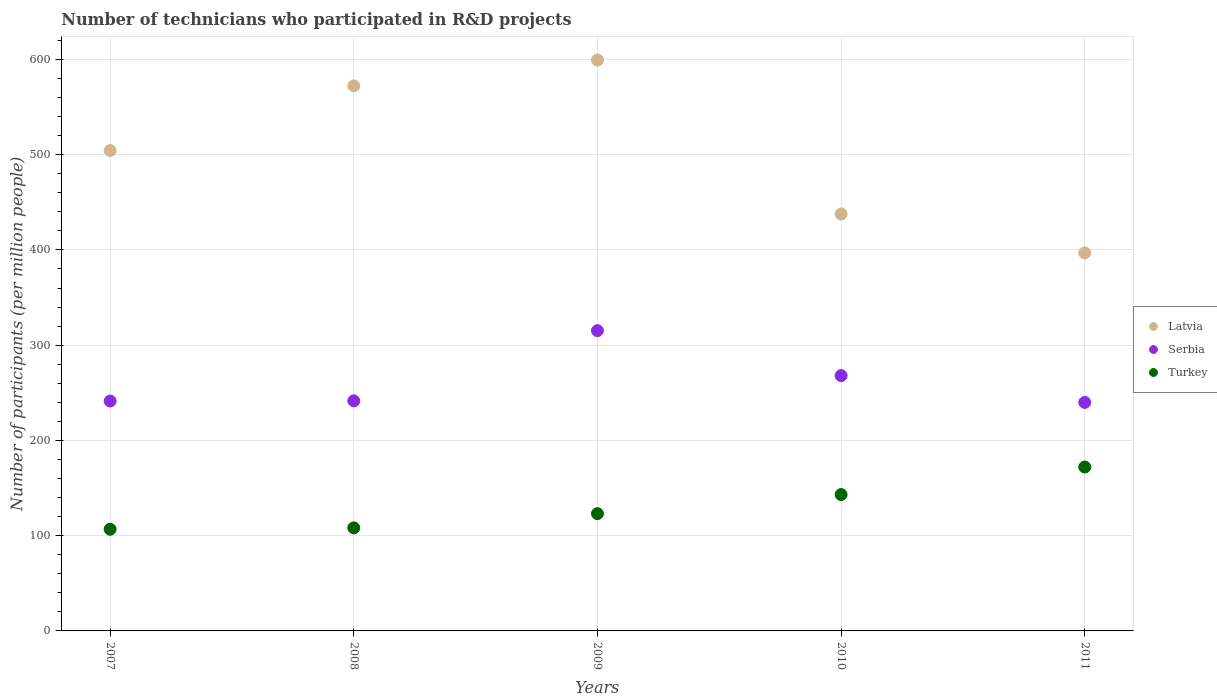What is the number of technicians who participated in R&D projects in Serbia in 2009?
Make the answer very short. 315.25. Across all years, what is the maximum number of technicians who participated in R&D projects in Latvia?
Ensure brevity in your answer.  599.35. Across all years, what is the minimum number of technicians who participated in R&D projects in Turkey?
Make the answer very short. 106.74. What is the total number of technicians who participated in R&D projects in Serbia in the graph?
Keep it short and to the point. 1306.11. What is the difference between the number of technicians who participated in R&D projects in Serbia in 2008 and that in 2009?
Give a very brief answer. -73.67. What is the difference between the number of technicians who participated in R&D projects in Turkey in 2009 and the number of technicians who participated in R&D projects in Latvia in 2008?
Make the answer very short. -449.12. What is the average number of technicians who participated in R&D projects in Serbia per year?
Offer a very short reply. 261.22. In the year 2007, what is the difference between the number of technicians who participated in R&D projects in Serbia and number of technicians who participated in R&D projects in Latvia?
Give a very brief answer. -262.94. What is the ratio of the number of technicians who participated in R&D projects in Latvia in 2008 to that in 2011?
Provide a short and direct response. 1.44. Is the number of technicians who participated in R&D projects in Latvia in 2009 less than that in 2010?
Your response must be concise. No. Is the difference between the number of technicians who participated in R&D projects in Serbia in 2009 and 2011 greater than the difference between the number of technicians who participated in R&D projects in Latvia in 2009 and 2011?
Offer a very short reply. No. What is the difference between the highest and the second highest number of technicians who participated in R&D projects in Latvia?
Your answer should be compact. 27.11. What is the difference between the highest and the lowest number of technicians who participated in R&D projects in Turkey?
Provide a succinct answer. 65.34. Does the number of technicians who participated in R&D projects in Serbia monotonically increase over the years?
Give a very brief answer. No. Is the number of technicians who participated in R&D projects in Latvia strictly greater than the number of technicians who participated in R&D projects in Serbia over the years?
Provide a succinct answer. Yes. Is the number of technicians who participated in R&D projects in Latvia strictly less than the number of technicians who participated in R&D projects in Serbia over the years?
Provide a short and direct response. No. How many dotlines are there?
Offer a terse response. 3. How many years are there in the graph?
Provide a short and direct response. 5. Are the values on the major ticks of Y-axis written in scientific E-notation?
Keep it short and to the point. No. Where does the legend appear in the graph?
Provide a succinct answer. Center right. How many legend labels are there?
Give a very brief answer. 3. What is the title of the graph?
Offer a very short reply. Number of technicians who participated in R&D projects. What is the label or title of the X-axis?
Provide a succinct answer. Years. What is the label or title of the Y-axis?
Provide a succinct answer. Number of participants (per million people). What is the Number of participants (per million people) of Latvia in 2007?
Provide a succinct answer. 504.29. What is the Number of participants (per million people) in Serbia in 2007?
Ensure brevity in your answer.  241.35. What is the Number of participants (per million people) of Turkey in 2007?
Give a very brief answer. 106.74. What is the Number of participants (per million people) of Latvia in 2008?
Provide a short and direct response. 572.24. What is the Number of participants (per million people) in Serbia in 2008?
Make the answer very short. 241.58. What is the Number of participants (per million people) of Turkey in 2008?
Keep it short and to the point. 108.21. What is the Number of participants (per million people) of Latvia in 2009?
Offer a very short reply. 599.35. What is the Number of participants (per million people) in Serbia in 2009?
Make the answer very short. 315.25. What is the Number of participants (per million people) in Turkey in 2009?
Your answer should be very brief. 123.12. What is the Number of participants (per million people) of Latvia in 2010?
Provide a succinct answer. 437.69. What is the Number of participants (per million people) in Serbia in 2010?
Give a very brief answer. 268.03. What is the Number of participants (per million people) in Turkey in 2010?
Your answer should be compact. 143.16. What is the Number of participants (per million people) in Latvia in 2011?
Offer a very short reply. 396.87. What is the Number of participants (per million people) of Serbia in 2011?
Ensure brevity in your answer.  239.9. What is the Number of participants (per million people) in Turkey in 2011?
Offer a terse response. 172.08. Across all years, what is the maximum Number of participants (per million people) of Latvia?
Ensure brevity in your answer.  599.35. Across all years, what is the maximum Number of participants (per million people) of Serbia?
Your response must be concise. 315.25. Across all years, what is the maximum Number of participants (per million people) of Turkey?
Give a very brief answer. 172.08. Across all years, what is the minimum Number of participants (per million people) of Latvia?
Provide a succinct answer. 396.87. Across all years, what is the minimum Number of participants (per million people) in Serbia?
Keep it short and to the point. 239.9. Across all years, what is the minimum Number of participants (per million people) in Turkey?
Offer a very short reply. 106.74. What is the total Number of participants (per million people) in Latvia in the graph?
Ensure brevity in your answer.  2510.43. What is the total Number of participants (per million people) of Serbia in the graph?
Keep it short and to the point. 1306.11. What is the total Number of participants (per million people) in Turkey in the graph?
Your response must be concise. 653.3. What is the difference between the Number of participants (per million people) in Latvia in 2007 and that in 2008?
Keep it short and to the point. -67.95. What is the difference between the Number of participants (per million people) in Serbia in 2007 and that in 2008?
Ensure brevity in your answer.  -0.23. What is the difference between the Number of participants (per million people) of Turkey in 2007 and that in 2008?
Your answer should be compact. -1.47. What is the difference between the Number of participants (per million people) in Latvia in 2007 and that in 2009?
Your response must be concise. -95.06. What is the difference between the Number of participants (per million people) of Serbia in 2007 and that in 2009?
Give a very brief answer. -73.9. What is the difference between the Number of participants (per million people) of Turkey in 2007 and that in 2009?
Your answer should be compact. -16.38. What is the difference between the Number of participants (per million people) of Latvia in 2007 and that in 2010?
Your answer should be very brief. 66.6. What is the difference between the Number of participants (per million people) of Serbia in 2007 and that in 2010?
Your response must be concise. -26.68. What is the difference between the Number of participants (per million people) of Turkey in 2007 and that in 2010?
Provide a short and direct response. -36.42. What is the difference between the Number of participants (per million people) in Latvia in 2007 and that in 2011?
Provide a succinct answer. 107.42. What is the difference between the Number of participants (per million people) in Serbia in 2007 and that in 2011?
Offer a terse response. 1.45. What is the difference between the Number of participants (per million people) in Turkey in 2007 and that in 2011?
Your answer should be compact. -65.34. What is the difference between the Number of participants (per million people) in Latvia in 2008 and that in 2009?
Give a very brief answer. -27.11. What is the difference between the Number of participants (per million people) of Serbia in 2008 and that in 2009?
Provide a short and direct response. -73.67. What is the difference between the Number of participants (per million people) in Turkey in 2008 and that in 2009?
Make the answer very short. -14.91. What is the difference between the Number of participants (per million people) in Latvia in 2008 and that in 2010?
Provide a succinct answer. 134.55. What is the difference between the Number of participants (per million people) in Serbia in 2008 and that in 2010?
Offer a very short reply. -26.45. What is the difference between the Number of participants (per million people) in Turkey in 2008 and that in 2010?
Your answer should be compact. -34.95. What is the difference between the Number of participants (per million people) in Latvia in 2008 and that in 2011?
Give a very brief answer. 175.37. What is the difference between the Number of participants (per million people) in Serbia in 2008 and that in 2011?
Offer a very short reply. 1.69. What is the difference between the Number of participants (per million people) of Turkey in 2008 and that in 2011?
Your answer should be compact. -63.87. What is the difference between the Number of participants (per million people) of Latvia in 2009 and that in 2010?
Your answer should be very brief. 161.66. What is the difference between the Number of participants (per million people) in Serbia in 2009 and that in 2010?
Offer a terse response. 47.22. What is the difference between the Number of participants (per million people) in Turkey in 2009 and that in 2010?
Keep it short and to the point. -20.04. What is the difference between the Number of participants (per million people) of Latvia in 2009 and that in 2011?
Your answer should be very brief. 202.48. What is the difference between the Number of participants (per million people) of Serbia in 2009 and that in 2011?
Offer a terse response. 75.36. What is the difference between the Number of participants (per million people) of Turkey in 2009 and that in 2011?
Your response must be concise. -48.96. What is the difference between the Number of participants (per million people) of Latvia in 2010 and that in 2011?
Your answer should be compact. 40.82. What is the difference between the Number of participants (per million people) of Serbia in 2010 and that in 2011?
Your response must be concise. 28.13. What is the difference between the Number of participants (per million people) of Turkey in 2010 and that in 2011?
Your answer should be compact. -28.92. What is the difference between the Number of participants (per million people) in Latvia in 2007 and the Number of participants (per million people) in Serbia in 2008?
Provide a short and direct response. 262.71. What is the difference between the Number of participants (per million people) in Latvia in 2007 and the Number of participants (per million people) in Turkey in 2008?
Give a very brief answer. 396.08. What is the difference between the Number of participants (per million people) in Serbia in 2007 and the Number of participants (per million people) in Turkey in 2008?
Provide a succinct answer. 133.14. What is the difference between the Number of participants (per million people) in Latvia in 2007 and the Number of participants (per million people) in Serbia in 2009?
Your answer should be very brief. 189.04. What is the difference between the Number of participants (per million people) in Latvia in 2007 and the Number of participants (per million people) in Turkey in 2009?
Make the answer very short. 381.17. What is the difference between the Number of participants (per million people) of Serbia in 2007 and the Number of participants (per million people) of Turkey in 2009?
Provide a succinct answer. 118.23. What is the difference between the Number of participants (per million people) of Latvia in 2007 and the Number of participants (per million people) of Serbia in 2010?
Provide a succinct answer. 236.26. What is the difference between the Number of participants (per million people) in Latvia in 2007 and the Number of participants (per million people) in Turkey in 2010?
Provide a short and direct response. 361.13. What is the difference between the Number of participants (per million people) in Serbia in 2007 and the Number of participants (per million people) in Turkey in 2010?
Provide a succinct answer. 98.19. What is the difference between the Number of participants (per million people) of Latvia in 2007 and the Number of participants (per million people) of Serbia in 2011?
Your answer should be compact. 264.39. What is the difference between the Number of participants (per million people) of Latvia in 2007 and the Number of participants (per million people) of Turkey in 2011?
Give a very brief answer. 332.21. What is the difference between the Number of participants (per million people) in Serbia in 2007 and the Number of participants (per million people) in Turkey in 2011?
Offer a very short reply. 69.27. What is the difference between the Number of participants (per million people) in Latvia in 2008 and the Number of participants (per million people) in Serbia in 2009?
Provide a succinct answer. 256.99. What is the difference between the Number of participants (per million people) in Latvia in 2008 and the Number of participants (per million people) in Turkey in 2009?
Provide a succinct answer. 449.12. What is the difference between the Number of participants (per million people) of Serbia in 2008 and the Number of participants (per million people) of Turkey in 2009?
Your response must be concise. 118.46. What is the difference between the Number of participants (per million people) of Latvia in 2008 and the Number of participants (per million people) of Serbia in 2010?
Make the answer very short. 304.21. What is the difference between the Number of participants (per million people) of Latvia in 2008 and the Number of participants (per million people) of Turkey in 2010?
Your answer should be very brief. 429.08. What is the difference between the Number of participants (per million people) in Serbia in 2008 and the Number of participants (per million people) in Turkey in 2010?
Your response must be concise. 98.42. What is the difference between the Number of participants (per million people) of Latvia in 2008 and the Number of participants (per million people) of Serbia in 2011?
Your answer should be compact. 332.34. What is the difference between the Number of participants (per million people) in Latvia in 2008 and the Number of participants (per million people) in Turkey in 2011?
Your response must be concise. 400.16. What is the difference between the Number of participants (per million people) in Serbia in 2008 and the Number of participants (per million people) in Turkey in 2011?
Your answer should be very brief. 69.5. What is the difference between the Number of participants (per million people) of Latvia in 2009 and the Number of participants (per million people) of Serbia in 2010?
Your answer should be very brief. 331.32. What is the difference between the Number of participants (per million people) of Latvia in 2009 and the Number of participants (per million people) of Turkey in 2010?
Offer a terse response. 456.19. What is the difference between the Number of participants (per million people) in Serbia in 2009 and the Number of participants (per million people) in Turkey in 2010?
Keep it short and to the point. 172.09. What is the difference between the Number of participants (per million people) in Latvia in 2009 and the Number of participants (per million people) in Serbia in 2011?
Provide a succinct answer. 359.45. What is the difference between the Number of participants (per million people) in Latvia in 2009 and the Number of participants (per million people) in Turkey in 2011?
Provide a succinct answer. 427.27. What is the difference between the Number of participants (per million people) in Serbia in 2009 and the Number of participants (per million people) in Turkey in 2011?
Your response must be concise. 143.17. What is the difference between the Number of participants (per million people) of Latvia in 2010 and the Number of participants (per million people) of Serbia in 2011?
Provide a short and direct response. 197.79. What is the difference between the Number of participants (per million people) of Latvia in 2010 and the Number of participants (per million people) of Turkey in 2011?
Keep it short and to the point. 265.61. What is the difference between the Number of participants (per million people) in Serbia in 2010 and the Number of participants (per million people) in Turkey in 2011?
Offer a very short reply. 95.95. What is the average Number of participants (per million people) of Latvia per year?
Give a very brief answer. 502.09. What is the average Number of participants (per million people) in Serbia per year?
Make the answer very short. 261.22. What is the average Number of participants (per million people) in Turkey per year?
Your answer should be compact. 130.66. In the year 2007, what is the difference between the Number of participants (per million people) of Latvia and Number of participants (per million people) of Serbia?
Keep it short and to the point. 262.94. In the year 2007, what is the difference between the Number of participants (per million people) of Latvia and Number of participants (per million people) of Turkey?
Your answer should be compact. 397.55. In the year 2007, what is the difference between the Number of participants (per million people) in Serbia and Number of participants (per million people) in Turkey?
Your response must be concise. 134.61. In the year 2008, what is the difference between the Number of participants (per million people) of Latvia and Number of participants (per million people) of Serbia?
Your answer should be compact. 330.66. In the year 2008, what is the difference between the Number of participants (per million people) in Latvia and Number of participants (per million people) in Turkey?
Give a very brief answer. 464.03. In the year 2008, what is the difference between the Number of participants (per million people) in Serbia and Number of participants (per million people) in Turkey?
Provide a succinct answer. 133.37. In the year 2009, what is the difference between the Number of participants (per million people) in Latvia and Number of participants (per million people) in Serbia?
Provide a succinct answer. 284.09. In the year 2009, what is the difference between the Number of participants (per million people) of Latvia and Number of participants (per million people) of Turkey?
Make the answer very short. 476.23. In the year 2009, what is the difference between the Number of participants (per million people) in Serbia and Number of participants (per million people) in Turkey?
Provide a short and direct response. 192.13. In the year 2010, what is the difference between the Number of participants (per million people) in Latvia and Number of participants (per million people) in Serbia?
Offer a terse response. 169.66. In the year 2010, what is the difference between the Number of participants (per million people) of Latvia and Number of participants (per million people) of Turkey?
Your answer should be very brief. 294.53. In the year 2010, what is the difference between the Number of participants (per million people) of Serbia and Number of participants (per million people) of Turkey?
Your answer should be very brief. 124.87. In the year 2011, what is the difference between the Number of participants (per million people) in Latvia and Number of participants (per million people) in Serbia?
Ensure brevity in your answer.  156.97. In the year 2011, what is the difference between the Number of participants (per million people) in Latvia and Number of participants (per million people) in Turkey?
Your answer should be very brief. 224.79. In the year 2011, what is the difference between the Number of participants (per million people) of Serbia and Number of participants (per million people) of Turkey?
Offer a very short reply. 67.82. What is the ratio of the Number of participants (per million people) in Latvia in 2007 to that in 2008?
Offer a terse response. 0.88. What is the ratio of the Number of participants (per million people) of Serbia in 2007 to that in 2008?
Keep it short and to the point. 1. What is the ratio of the Number of participants (per million people) in Turkey in 2007 to that in 2008?
Keep it short and to the point. 0.99. What is the ratio of the Number of participants (per million people) of Latvia in 2007 to that in 2009?
Offer a very short reply. 0.84. What is the ratio of the Number of participants (per million people) of Serbia in 2007 to that in 2009?
Your response must be concise. 0.77. What is the ratio of the Number of participants (per million people) in Turkey in 2007 to that in 2009?
Your answer should be compact. 0.87. What is the ratio of the Number of participants (per million people) of Latvia in 2007 to that in 2010?
Provide a succinct answer. 1.15. What is the ratio of the Number of participants (per million people) of Serbia in 2007 to that in 2010?
Your answer should be very brief. 0.9. What is the ratio of the Number of participants (per million people) of Turkey in 2007 to that in 2010?
Provide a succinct answer. 0.75. What is the ratio of the Number of participants (per million people) in Latvia in 2007 to that in 2011?
Give a very brief answer. 1.27. What is the ratio of the Number of participants (per million people) in Serbia in 2007 to that in 2011?
Provide a succinct answer. 1.01. What is the ratio of the Number of participants (per million people) in Turkey in 2007 to that in 2011?
Offer a terse response. 0.62. What is the ratio of the Number of participants (per million people) in Latvia in 2008 to that in 2009?
Your answer should be compact. 0.95. What is the ratio of the Number of participants (per million people) of Serbia in 2008 to that in 2009?
Make the answer very short. 0.77. What is the ratio of the Number of participants (per million people) in Turkey in 2008 to that in 2009?
Provide a short and direct response. 0.88. What is the ratio of the Number of participants (per million people) in Latvia in 2008 to that in 2010?
Ensure brevity in your answer.  1.31. What is the ratio of the Number of participants (per million people) in Serbia in 2008 to that in 2010?
Make the answer very short. 0.9. What is the ratio of the Number of participants (per million people) of Turkey in 2008 to that in 2010?
Provide a short and direct response. 0.76. What is the ratio of the Number of participants (per million people) of Latvia in 2008 to that in 2011?
Keep it short and to the point. 1.44. What is the ratio of the Number of participants (per million people) in Turkey in 2008 to that in 2011?
Keep it short and to the point. 0.63. What is the ratio of the Number of participants (per million people) of Latvia in 2009 to that in 2010?
Your answer should be very brief. 1.37. What is the ratio of the Number of participants (per million people) of Serbia in 2009 to that in 2010?
Keep it short and to the point. 1.18. What is the ratio of the Number of participants (per million people) in Turkey in 2009 to that in 2010?
Keep it short and to the point. 0.86. What is the ratio of the Number of participants (per million people) of Latvia in 2009 to that in 2011?
Make the answer very short. 1.51. What is the ratio of the Number of participants (per million people) of Serbia in 2009 to that in 2011?
Offer a very short reply. 1.31. What is the ratio of the Number of participants (per million people) in Turkey in 2009 to that in 2011?
Your response must be concise. 0.72. What is the ratio of the Number of participants (per million people) of Latvia in 2010 to that in 2011?
Offer a very short reply. 1.1. What is the ratio of the Number of participants (per million people) of Serbia in 2010 to that in 2011?
Give a very brief answer. 1.12. What is the ratio of the Number of participants (per million people) of Turkey in 2010 to that in 2011?
Offer a terse response. 0.83. What is the difference between the highest and the second highest Number of participants (per million people) in Latvia?
Provide a short and direct response. 27.11. What is the difference between the highest and the second highest Number of participants (per million people) in Serbia?
Your answer should be compact. 47.22. What is the difference between the highest and the second highest Number of participants (per million people) in Turkey?
Offer a very short reply. 28.92. What is the difference between the highest and the lowest Number of participants (per million people) in Latvia?
Offer a terse response. 202.48. What is the difference between the highest and the lowest Number of participants (per million people) in Serbia?
Make the answer very short. 75.36. What is the difference between the highest and the lowest Number of participants (per million people) of Turkey?
Your answer should be very brief. 65.34. 